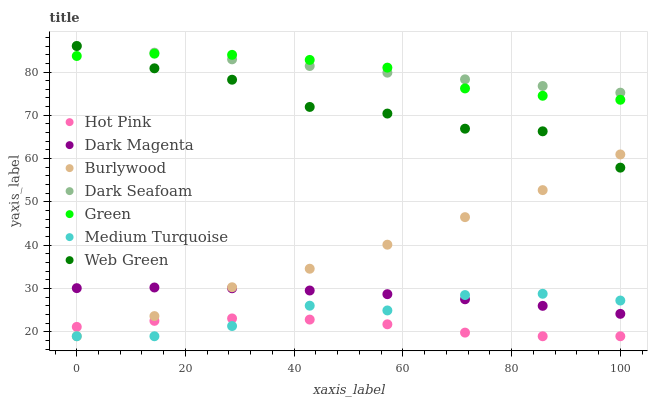Does Hot Pink have the minimum area under the curve?
Answer yes or no. Yes. Does Dark Seafoam have the maximum area under the curve?
Answer yes or no. Yes. Does Burlywood have the minimum area under the curve?
Answer yes or no. No. Does Burlywood have the maximum area under the curve?
Answer yes or no. No. Is Dark Seafoam the smoothest?
Answer yes or no. Yes. Is Web Green the roughest?
Answer yes or no. Yes. Is Burlywood the smoothest?
Answer yes or no. No. Is Burlywood the roughest?
Answer yes or no. No. Does Burlywood have the lowest value?
Answer yes or no. Yes. Does Web Green have the lowest value?
Answer yes or no. No. Does Dark Seafoam have the highest value?
Answer yes or no. Yes. Does Burlywood have the highest value?
Answer yes or no. No. Is Hot Pink less than Dark Magenta?
Answer yes or no. Yes. Is Green greater than Hot Pink?
Answer yes or no. Yes. Does Dark Seafoam intersect Green?
Answer yes or no. Yes. Is Dark Seafoam less than Green?
Answer yes or no. No. Is Dark Seafoam greater than Green?
Answer yes or no. No. Does Hot Pink intersect Dark Magenta?
Answer yes or no. No. 